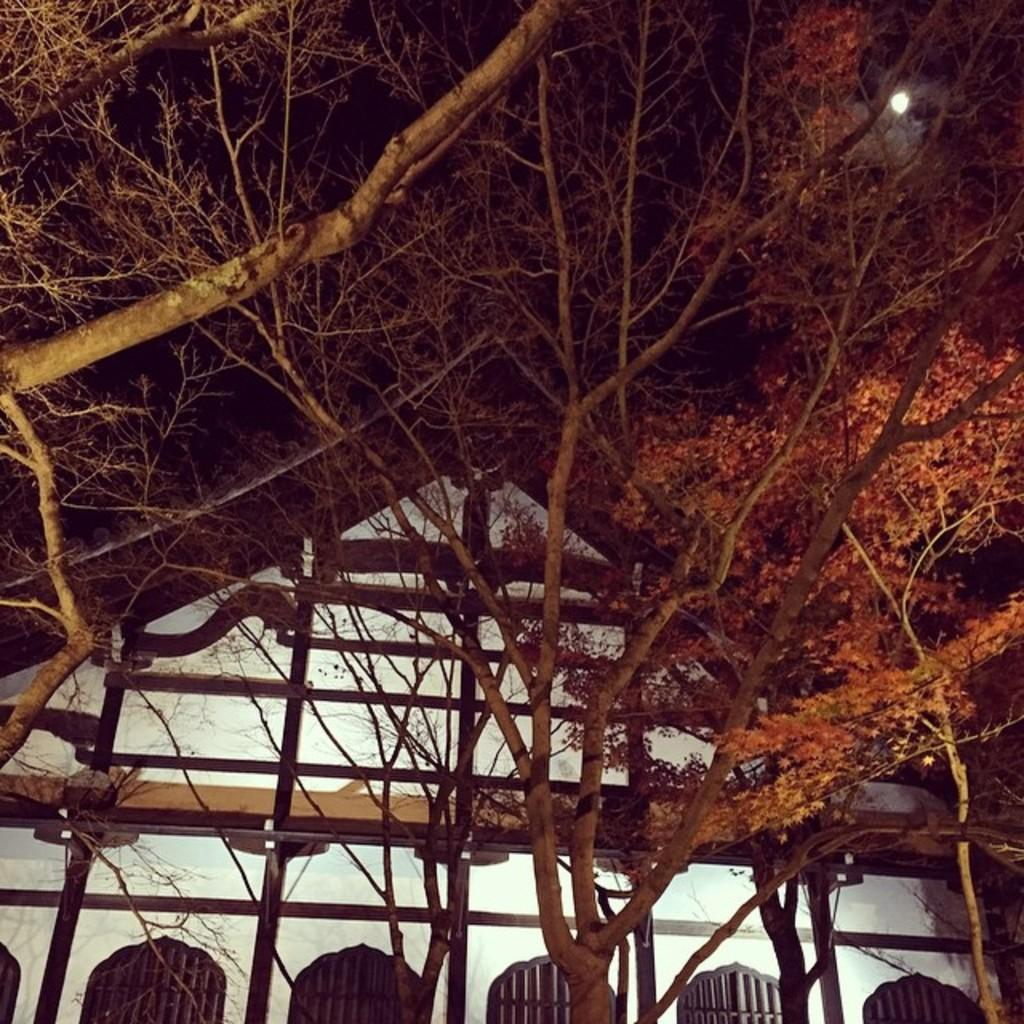What type of structure is visible in the image? There is a building in the image. What is the relationship between the building and the trees in the image? The building is behind trees in the image. What can be seen at the top of the image? The sky is visible at the top of the image. What celestial body is present in the sky? There is a moon in the sky. What type of book can be seen on the window ledge in the image? There is no book or window ledge present in the image. 